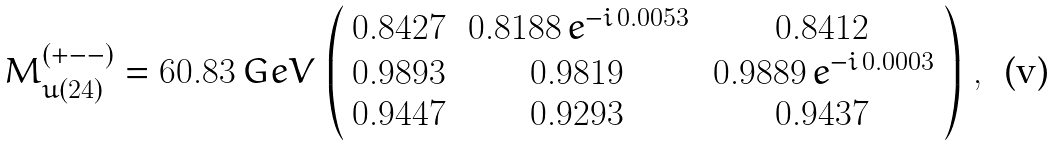Convert formula to latex. <formula><loc_0><loc_0><loc_500><loc_500>M _ { u ( 2 4 ) } ^ { ( + - - ) } = 6 0 . 8 3 \, G e V \, \left ( \begin{array} { c c c } 0 . 8 4 2 7 & \, 0 . 8 1 8 8 \, e ^ { - i \, 0 . 0 0 5 3 } & 0 . 8 4 1 2 \\ 0 . 9 8 9 3 & 0 . 9 8 1 9 & \, 0 . 9 8 8 9 \, e ^ { - i \, 0 . 0 0 0 3 } \\ 0 . 9 4 4 7 & 0 . 9 2 9 3 & 0 . 9 4 3 7 \end{array} \right ) \, ,</formula> 